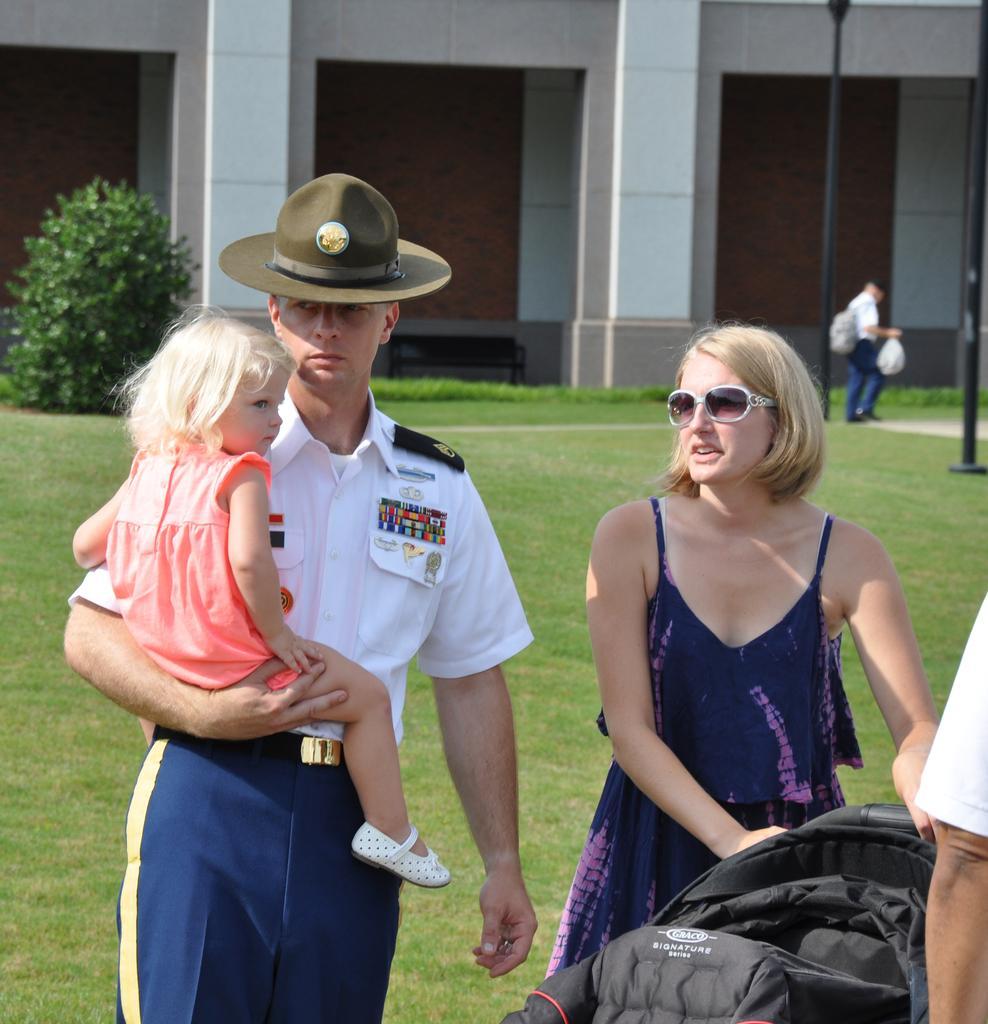Could you give a brief overview of what you see in this image? The man in white shirt and blue pant is holding the girl in his hand. Beside him, the woman in blue dress is holding a black color suitcase. At the bottom of the picture, we see grass. Behind them, we see the tree and a building which is in white color. In the right top of the picture, we see poles and a man in the white shirt is walking in the garden. This picture is clicked outside the building. 